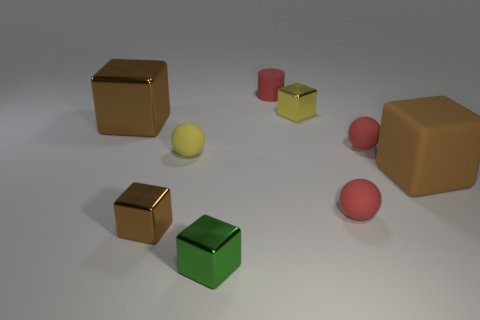Subtract all matte blocks. How many blocks are left? 4 Subtract all yellow blocks. How many blocks are left? 4 Subtract all cylinders. How many objects are left? 8 Subtract 1 balls. How many balls are left? 2 Subtract all yellow balls. How many brown blocks are left? 3 Subtract all green spheres. Subtract all purple cylinders. How many spheres are left? 3 Subtract all brown cylinders. Subtract all matte balls. How many objects are left? 6 Add 8 yellow metallic cubes. How many yellow metallic cubes are left? 9 Add 7 small green objects. How many small green objects exist? 8 Subtract 2 brown blocks. How many objects are left? 7 